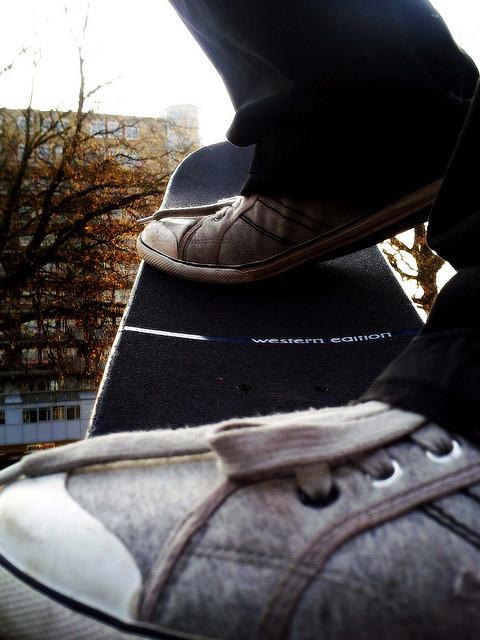Are there leaves on the tree?
Concise answer only. Yes. Is the skateboard in the air?
Answer briefly. Yes. What method of mass transit is shown?
Write a very short answer. Skateboard. 